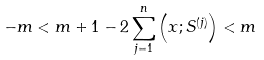<formula> <loc_0><loc_0><loc_500><loc_500>- m < m + 1 - 2 \sum _ { j = 1 } ^ { n } \left ( x ; S ^ { ( j ) } \right ) < m</formula> 